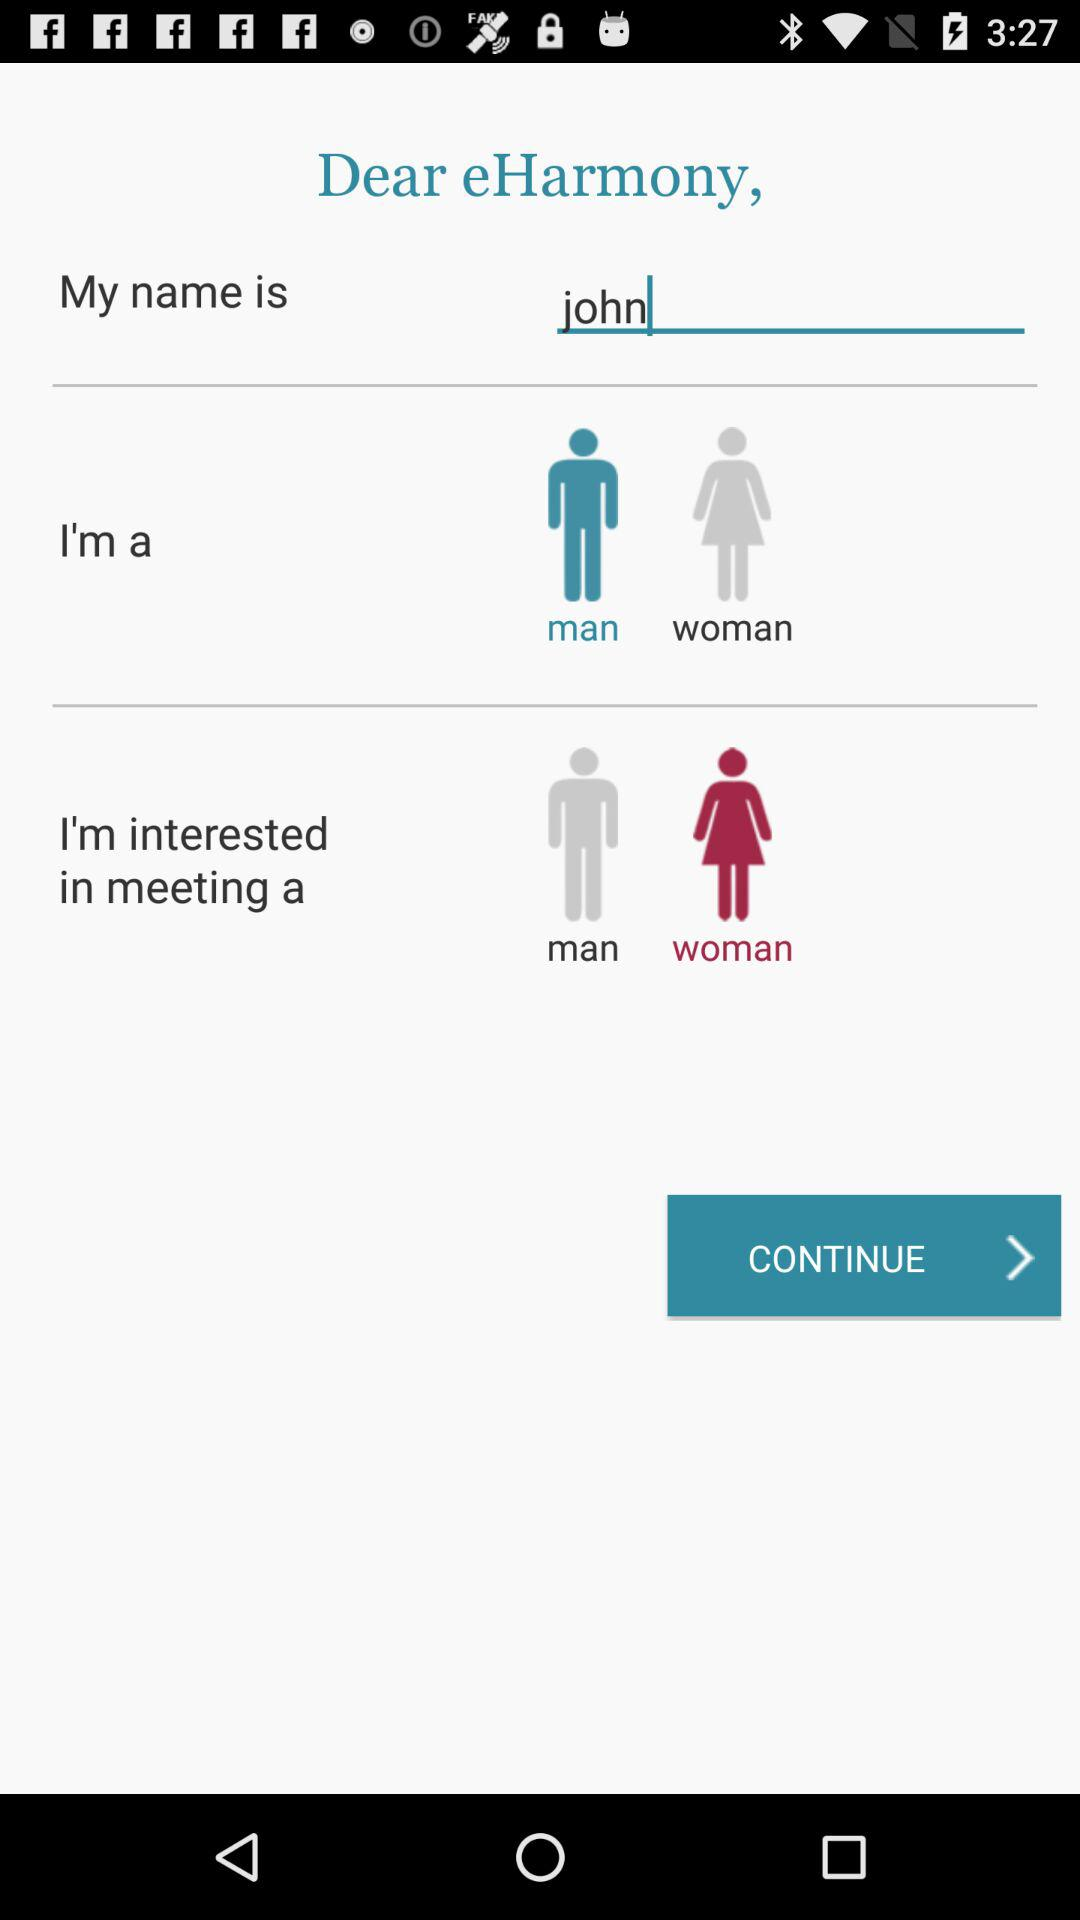What is the name? The name is John. 